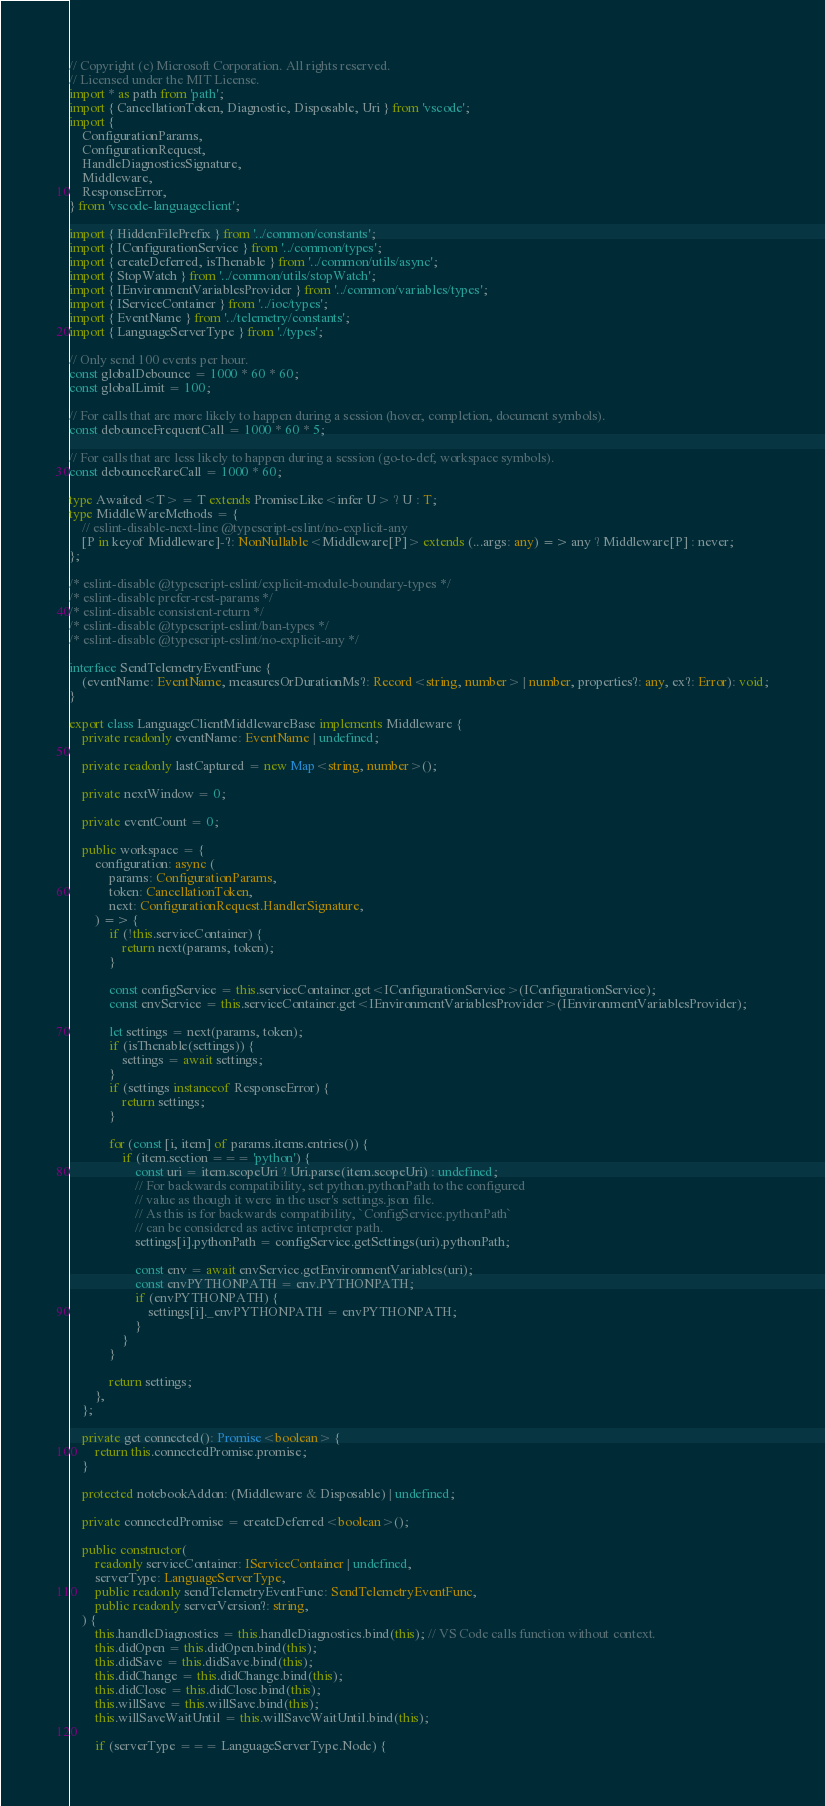Convert code to text. <code><loc_0><loc_0><loc_500><loc_500><_TypeScript_>// Copyright (c) Microsoft Corporation. All rights reserved.
// Licensed under the MIT License.
import * as path from 'path';
import { CancellationToken, Diagnostic, Disposable, Uri } from 'vscode';
import {
    ConfigurationParams,
    ConfigurationRequest,
    HandleDiagnosticsSignature,
    Middleware,
    ResponseError,
} from 'vscode-languageclient';

import { HiddenFilePrefix } from '../common/constants';
import { IConfigurationService } from '../common/types';
import { createDeferred, isThenable } from '../common/utils/async';
import { StopWatch } from '../common/utils/stopWatch';
import { IEnvironmentVariablesProvider } from '../common/variables/types';
import { IServiceContainer } from '../ioc/types';
import { EventName } from '../telemetry/constants';
import { LanguageServerType } from './types';

// Only send 100 events per hour.
const globalDebounce = 1000 * 60 * 60;
const globalLimit = 100;

// For calls that are more likely to happen during a session (hover, completion, document symbols).
const debounceFrequentCall = 1000 * 60 * 5;

// For calls that are less likely to happen during a session (go-to-def, workspace symbols).
const debounceRareCall = 1000 * 60;

type Awaited<T> = T extends PromiseLike<infer U> ? U : T;
type MiddleWareMethods = {
    // eslint-disable-next-line @typescript-eslint/no-explicit-any
    [P in keyof Middleware]-?: NonNullable<Middleware[P]> extends (...args: any) => any ? Middleware[P] : never;
};

/* eslint-disable @typescript-eslint/explicit-module-boundary-types */
/* eslint-disable prefer-rest-params */
/* eslint-disable consistent-return */
/* eslint-disable @typescript-eslint/ban-types */
/* eslint-disable @typescript-eslint/no-explicit-any */

interface SendTelemetryEventFunc {
    (eventName: EventName, measuresOrDurationMs?: Record<string, number> | number, properties?: any, ex?: Error): void;
}

export class LanguageClientMiddlewareBase implements Middleware {
    private readonly eventName: EventName | undefined;

    private readonly lastCaptured = new Map<string, number>();

    private nextWindow = 0;

    private eventCount = 0;

    public workspace = {
        configuration: async (
            params: ConfigurationParams,
            token: CancellationToken,
            next: ConfigurationRequest.HandlerSignature,
        ) => {
            if (!this.serviceContainer) {
                return next(params, token);
            }

            const configService = this.serviceContainer.get<IConfigurationService>(IConfigurationService);
            const envService = this.serviceContainer.get<IEnvironmentVariablesProvider>(IEnvironmentVariablesProvider);

            let settings = next(params, token);
            if (isThenable(settings)) {
                settings = await settings;
            }
            if (settings instanceof ResponseError) {
                return settings;
            }

            for (const [i, item] of params.items.entries()) {
                if (item.section === 'python') {
                    const uri = item.scopeUri ? Uri.parse(item.scopeUri) : undefined;
                    // For backwards compatibility, set python.pythonPath to the configured
                    // value as though it were in the user's settings.json file.
                    // As this is for backwards compatibility, `ConfigService.pythonPath`
                    // can be considered as active interpreter path.
                    settings[i].pythonPath = configService.getSettings(uri).pythonPath;

                    const env = await envService.getEnvironmentVariables(uri);
                    const envPYTHONPATH = env.PYTHONPATH;
                    if (envPYTHONPATH) {
                        settings[i]._envPYTHONPATH = envPYTHONPATH;
                    }
                }
            }

            return settings;
        },
    };

    private get connected(): Promise<boolean> {
        return this.connectedPromise.promise;
    }

    protected notebookAddon: (Middleware & Disposable) | undefined;

    private connectedPromise = createDeferred<boolean>();

    public constructor(
        readonly serviceContainer: IServiceContainer | undefined,
        serverType: LanguageServerType,
        public readonly sendTelemetryEventFunc: SendTelemetryEventFunc,
        public readonly serverVersion?: string,
    ) {
        this.handleDiagnostics = this.handleDiagnostics.bind(this); // VS Code calls function without context.
        this.didOpen = this.didOpen.bind(this);
        this.didSave = this.didSave.bind(this);
        this.didChange = this.didChange.bind(this);
        this.didClose = this.didClose.bind(this);
        this.willSave = this.willSave.bind(this);
        this.willSaveWaitUntil = this.willSaveWaitUntil.bind(this);

        if (serverType === LanguageServerType.Node) {</code> 